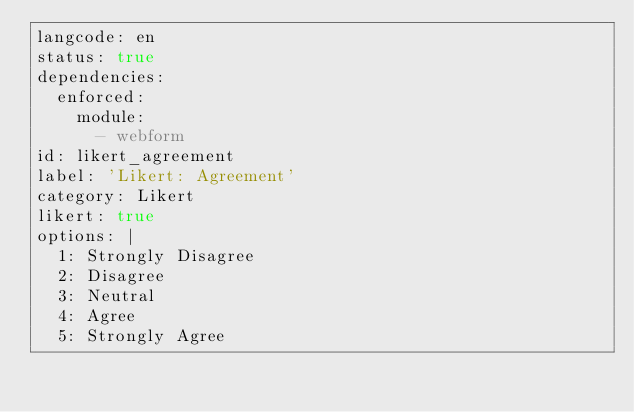Convert code to text. <code><loc_0><loc_0><loc_500><loc_500><_YAML_>langcode: en
status: true
dependencies:
  enforced:
    module:
      - webform
id: likert_agreement
label: 'Likert: Agreement'
category: Likert
likert: true
options: |
  1: Strongly Disagree
  2: Disagree
  3: Neutral
  4: Agree
  5: Strongly Agree
</code> 